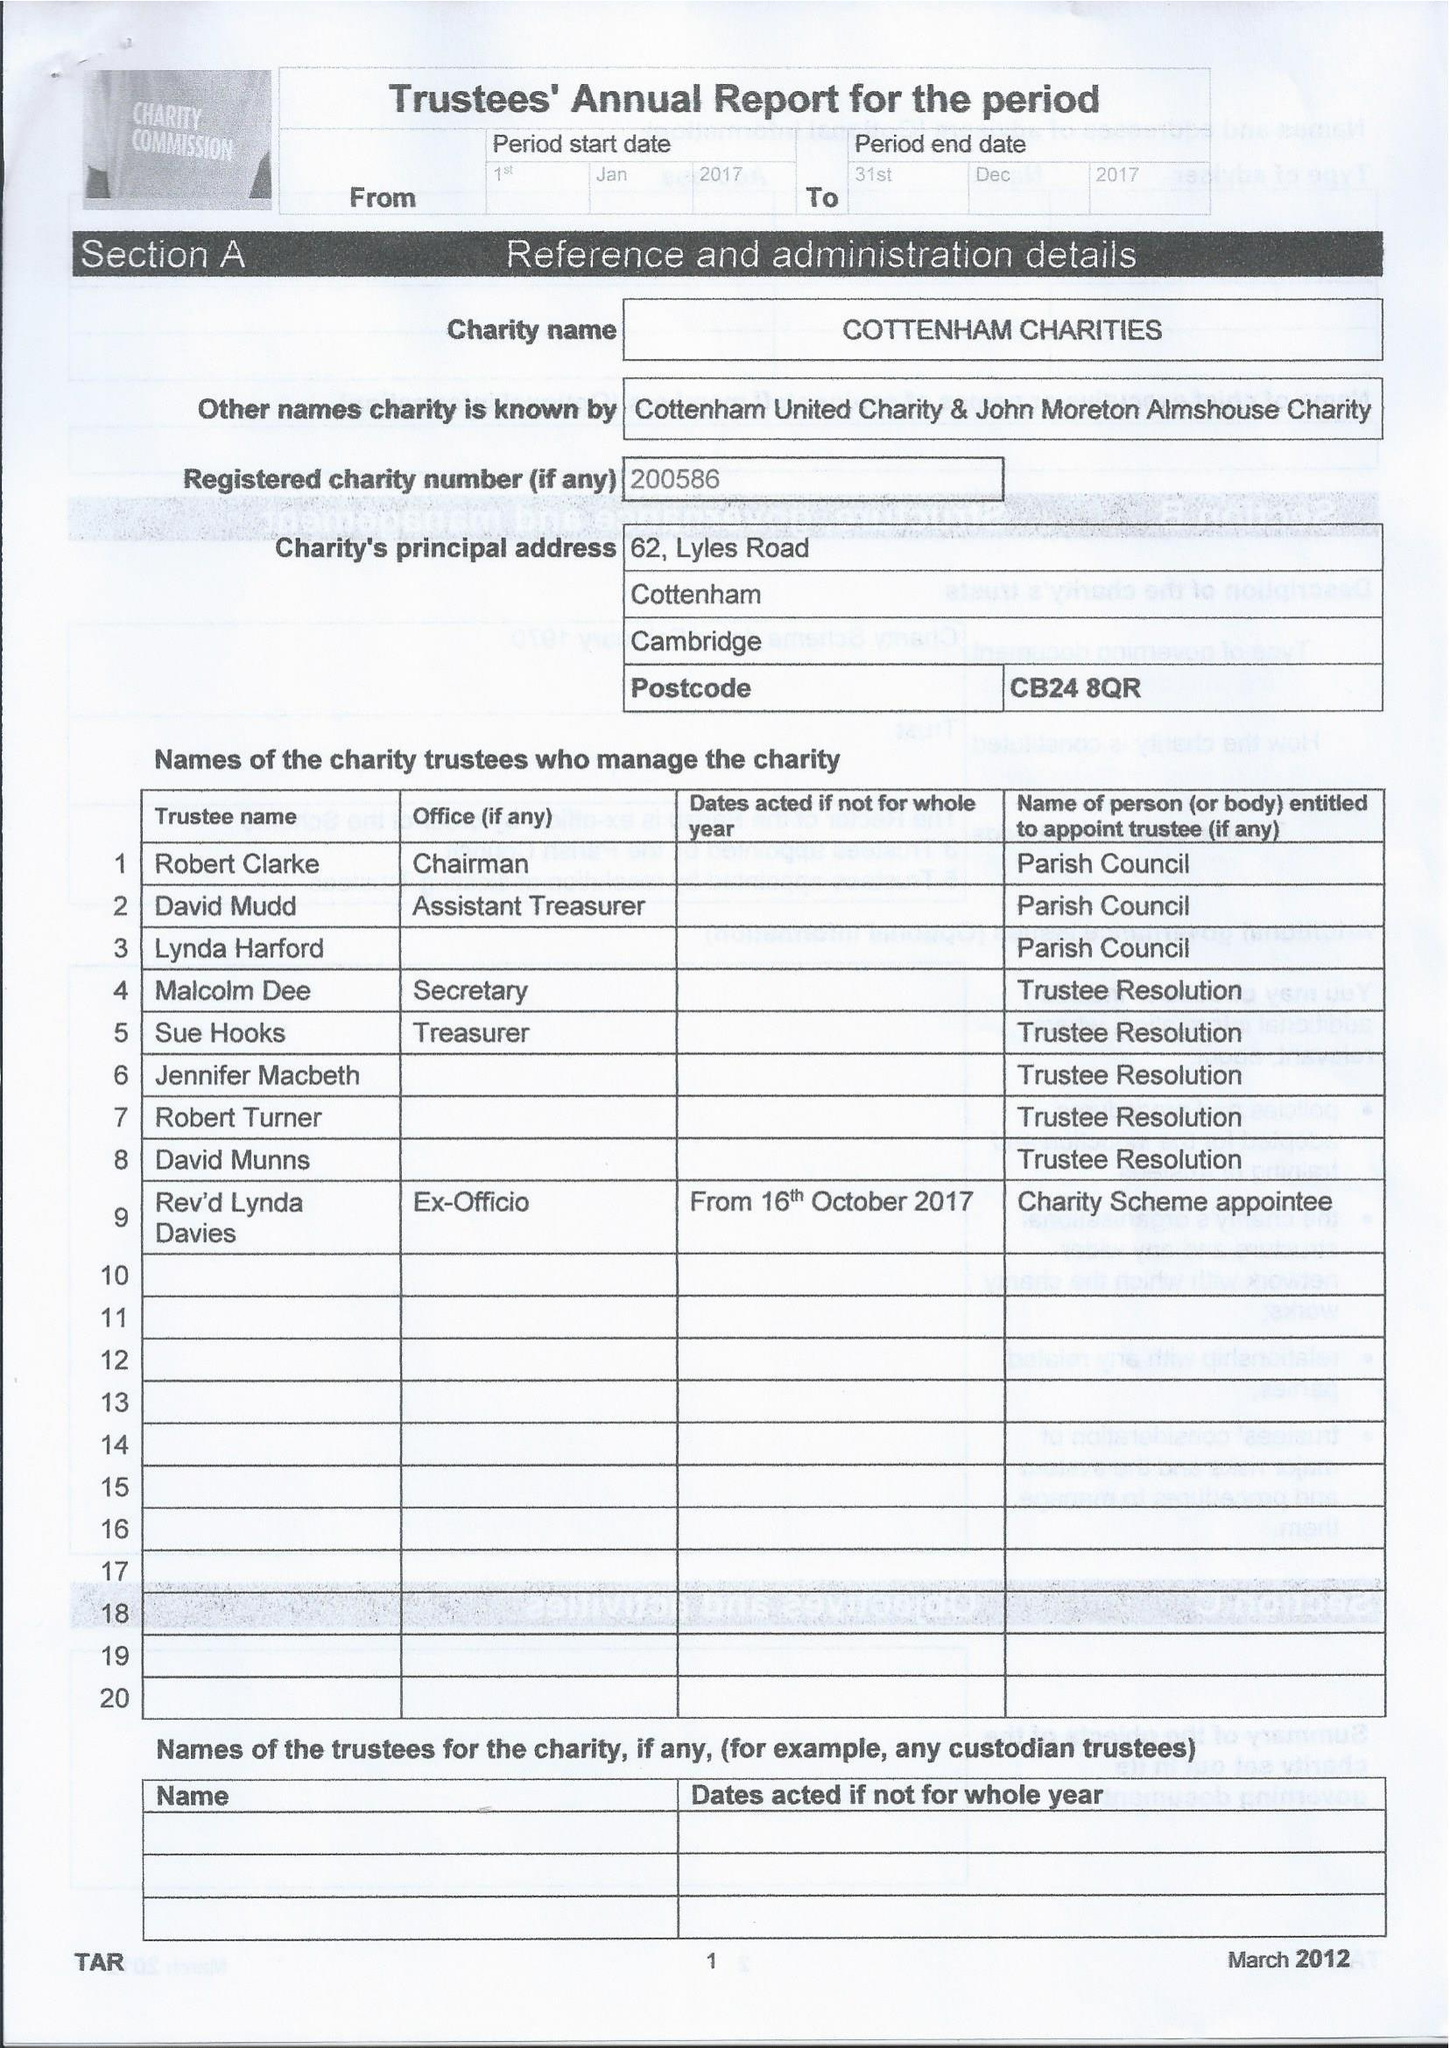What is the value for the address__street_line?
Answer the question using a single word or phrase. 62 LYLES ROAD 